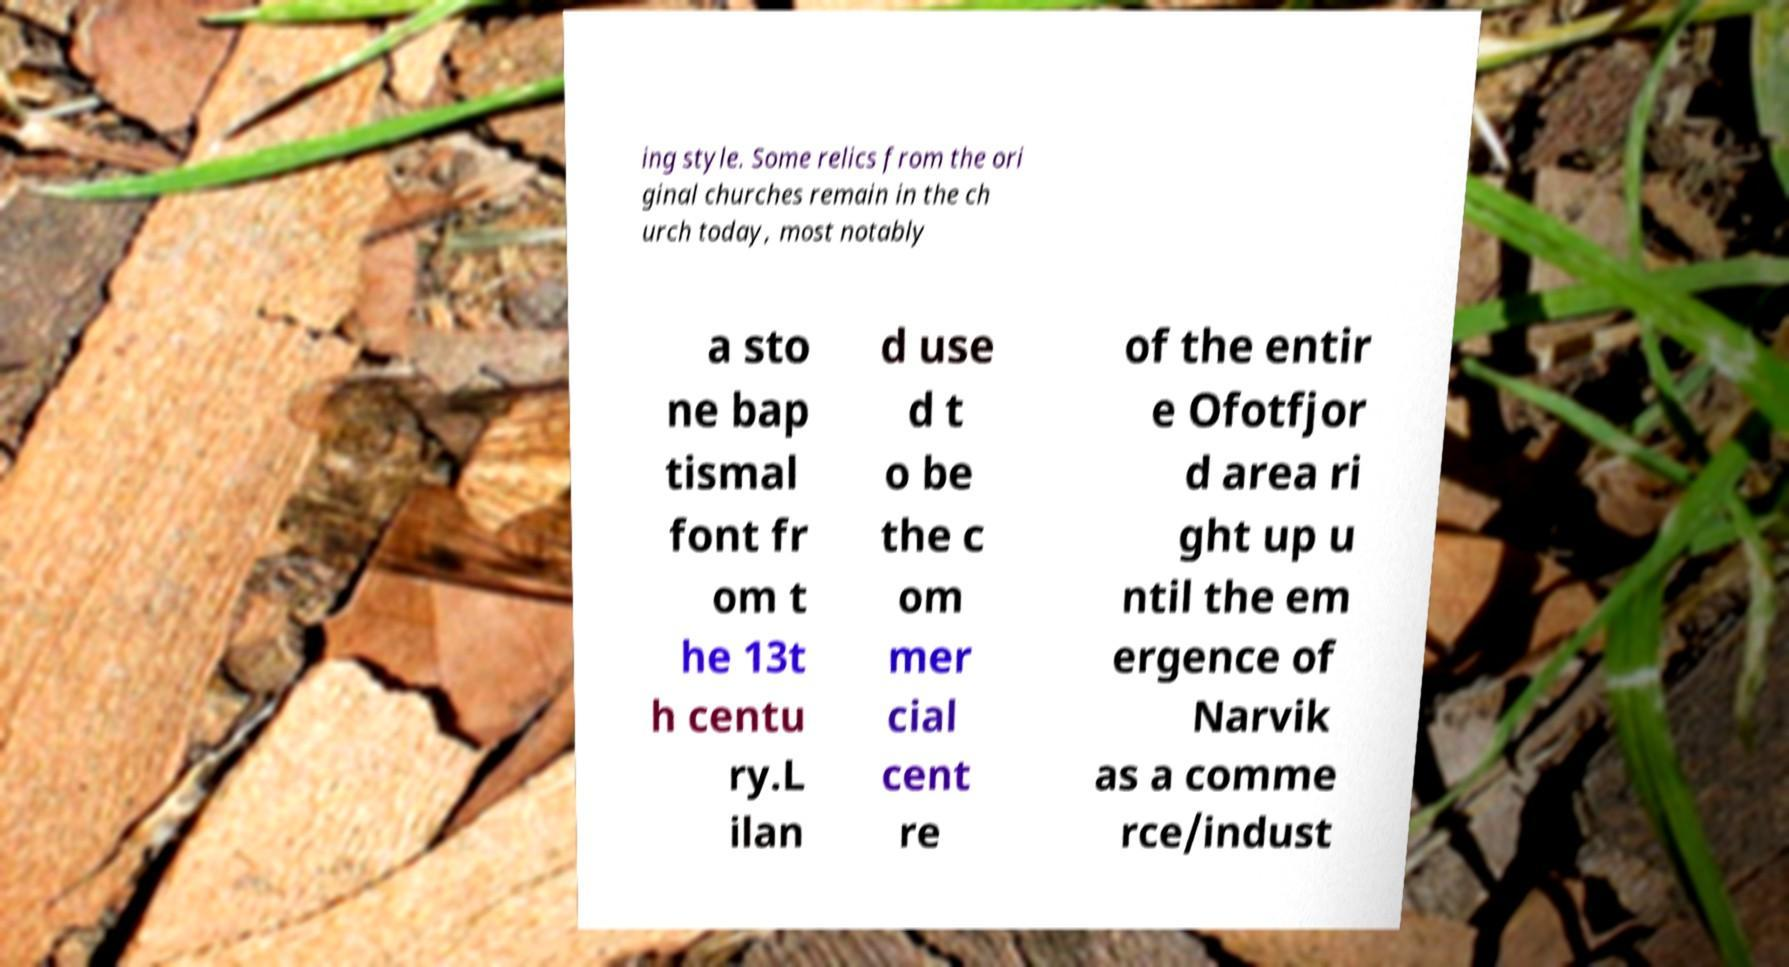Could you extract and type out the text from this image? ing style. Some relics from the ori ginal churches remain in the ch urch today, most notably a sto ne bap tismal font fr om t he 13t h centu ry.L ilan d use d t o be the c om mer cial cent re of the entir e Ofotfjor d area ri ght up u ntil the em ergence of Narvik as a comme rce/indust 